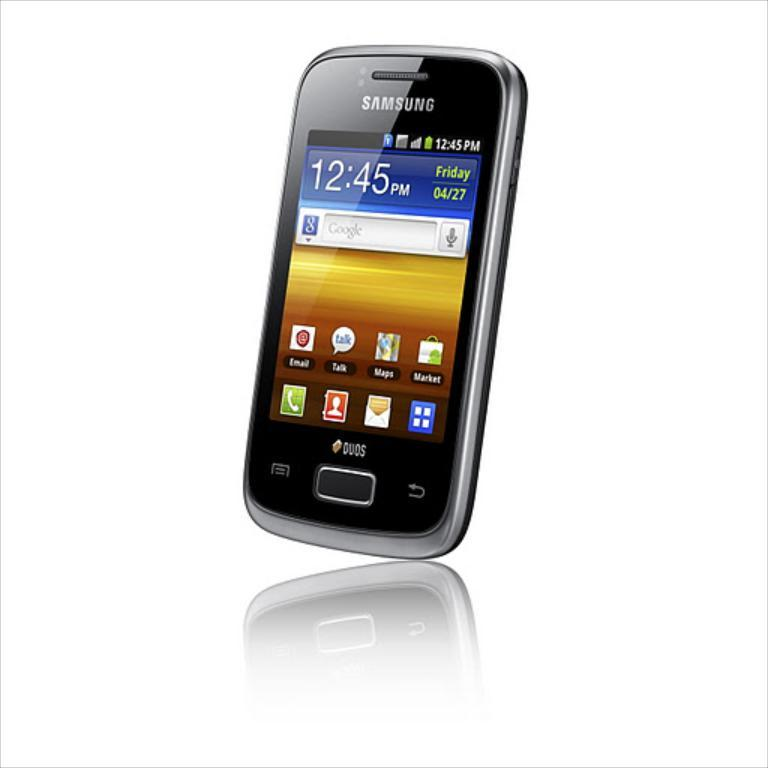<image>
Create a compact narrative representing the image presented. A Samsung smart phone showing the home page. 